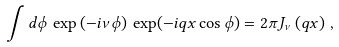Convert formula to latex. <formula><loc_0><loc_0><loc_500><loc_500>\int d \phi \, \exp \left ( - i \nu \phi \right ) \, \exp ( - i q x \cos \phi ) = 2 \pi J _ { \nu } \left ( q x \right ) \, ,</formula> 